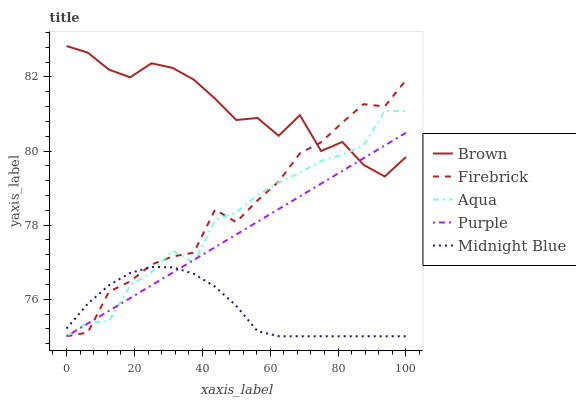Does Midnight Blue have the minimum area under the curve?
Answer yes or no. Yes. Does Brown have the maximum area under the curve?
Answer yes or no. Yes. Does Firebrick have the minimum area under the curve?
Answer yes or no. No. Does Firebrick have the maximum area under the curve?
Answer yes or no. No. Is Purple the smoothest?
Answer yes or no. Yes. Is Brown the roughest?
Answer yes or no. Yes. Is Firebrick the smoothest?
Answer yes or no. No. Is Firebrick the roughest?
Answer yes or no. No. Does Brown have the lowest value?
Answer yes or no. No. Does Firebrick have the highest value?
Answer yes or no. No. Is Midnight Blue less than Brown?
Answer yes or no. Yes. Is Brown greater than Midnight Blue?
Answer yes or no. Yes. Does Midnight Blue intersect Brown?
Answer yes or no. No. 